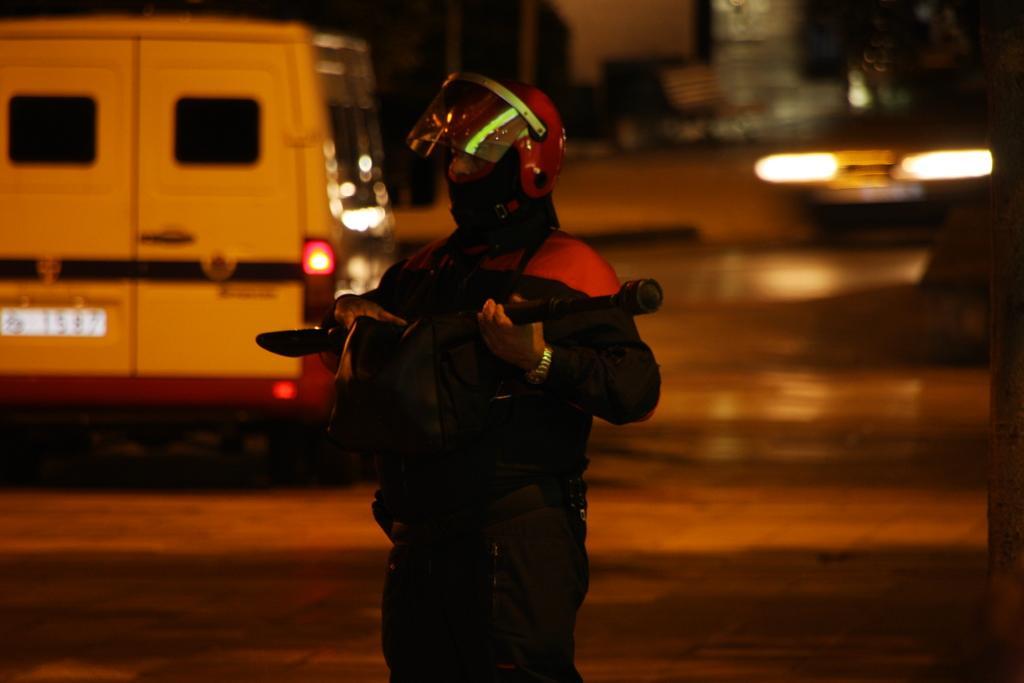How would you summarize this image in a sentence or two? In this image, we can see a person holding an object and wearing a helmet. Background we can see the blur view. Here we can see vehicles and few objects. 